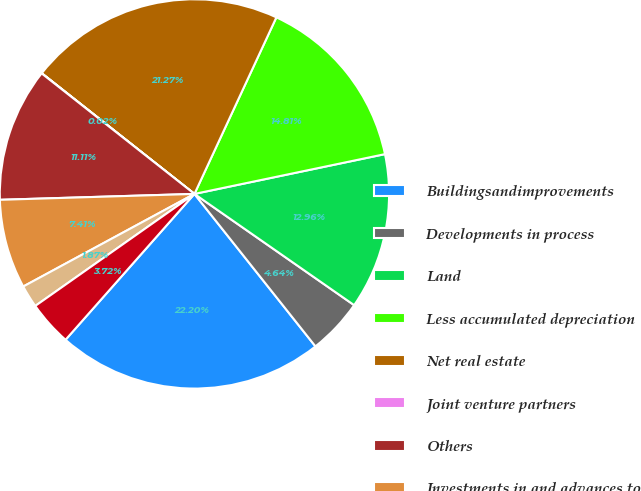<chart> <loc_0><loc_0><loc_500><loc_500><pie_chart><fcel>Buildingsandimprovements<fcel>Developments in process<fcel>Land<fcel>Less accumulated depreciation<fcel>Net real estate<fcel>Joint venture partners<fcel>Others<fcel>Investments in and advances to<fcel>Accounts receivable net of<fcel>Cash and cash equivalents<nl><fcel>22.2%<fcel>4.64%<fcel>12.96%<fcel>14.81%<fcel>21.27%<fcel>0.02%<fcel>11.11%<fcel>7.41%<fcel>1.87%<fcel>3.72%<nl></chart> 